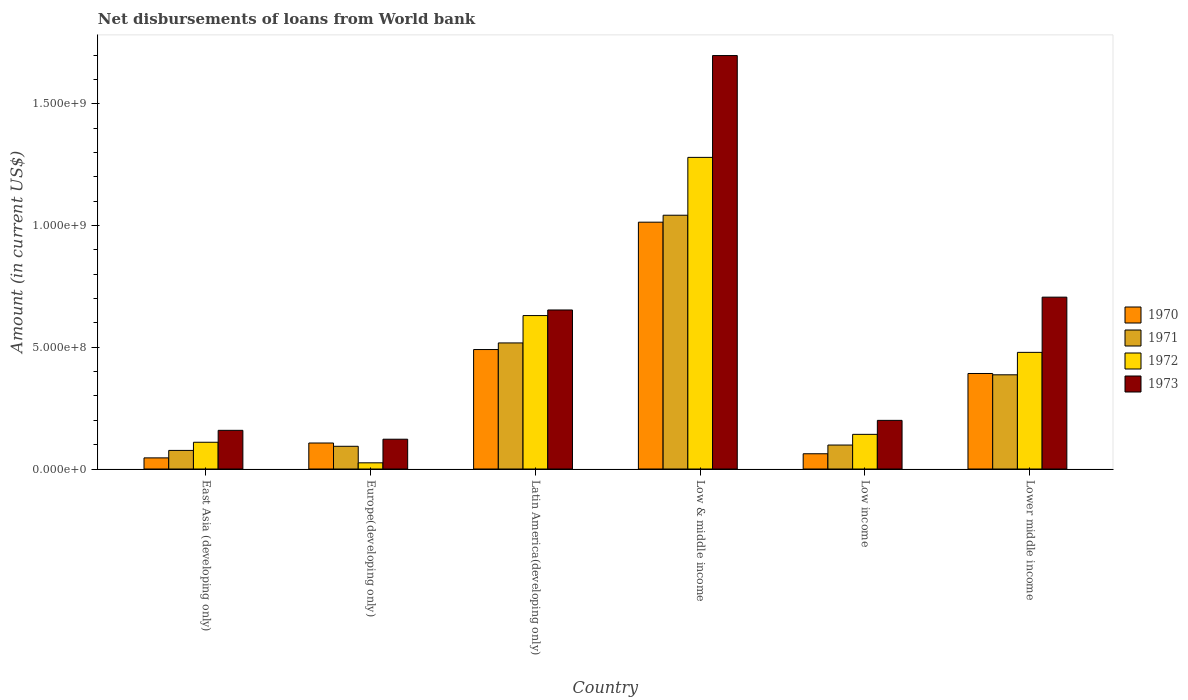How many different coloured bars are there?
Ensure brevity in your answer.  4. How many groups of bars are there?
Provide a succinct answer. 6. Are the number of bars per tick equal to the number of legend labels?
Provide a succinct answer. Yes. How many bars are there on the 4th tick from the left?
Offer a very short reply. 4. What is the label of the 2nd group of bars from the left?
Your answer should be compact. Europe(developing only). What is the amount of loan disbursed from World Bank in 1972 in Low income?
Keep it short and to the point. 1.42e+08. Across all countries, what is the maximum amount of loan disbursed from World Bank in 1970?
Give a very brief answer. 1.01e+09. Across all countries, what is the minimum amount of loan disbursed from World Bank in 1973?
Provide a succinct answer. 1.22e+08. In which country was the amount of loan disbursed from World Bank in 1972 maximum?
Offer a terse response. Low & middle income. In which country was the amount of loan disbursed from World Bank in 1970 minimum?
Offer a terse response. East Asia (developing only). What is the total amount of loan disbursed from World Bank in 1972 in the graph?
Keep it short and to the point. 2.67e+09. What is the difference between the amount of loan disbursed from World Bank in 1971 in Latin America(developing only) and that in Low income?
Offer a very short reply. 4.19e+08. What is the difference between the amount of loan disbursed from World Bank in 1973 in Low income and the amount of loan disbursed from World Bank in 1971 in Low & middle income?
Provide a succinct answer. -8.43e+08. What is the average amount of loan disbursed from World Bank in 1970 per country?
Ensure brevity in your answer.  3.52e+08. What is the difference between the amount of loan disbursed from World Bank of/in 1972 and amount of loan disbursed from World Bank of/in 1971 in Europe(developing only)?
Provide a short and direct response. -6.79e+07. What is the ratio of the amount of loan disbursed from World Bank in 1971 in East Asia (developing only) to that in Low & middle income?
Provide a short and direct response. 0.07. Is the difference between the amount of loan disbursed from World Bank in 1972 in East Asia (developing only) and Latin America(developing only) greater than the difference between the amount of loan disbursed from World Bank in 1971 in East Asia (developing only) and Latin America(developing only)?
Give a very brief answer. No. What is the difference between the highest and the second highest amount of loan disbursed from World Bank in 1973?
Keep it short and to the point. 1.05e+09. What is the difference between the highest and the lowest amount of loan disbursed from World Bank in 1973?
Ensure brevity in your answer.  1.58e+09. In how many countries, is the amount of loan disbursed from World Bank in 1970 greater than the average amount of loan disbursed from World Bank in 1970 taken over all countries?
Keep it short and to the point. 3. Is the sum of the amount of loan disbursed from World Bank in 1972 in Europe(developing only) and Low income greater than the maximum amount of loan disbursed from World Bank in 1973 across all countries?
Offer a very short reply. No. Is it the case that in every country, the sum of the amount of loan disbursed from World Bank in 1971 and amount of loan disbursed from World Bank in 1973 is greater than the sum of amount of loan disbursed from World Bank in 1972 and amount of loan disbursed from World Bank in 1970?
Make the answer very short. No. What does the 4th bar from the right in Lower middle income represents?
Provide a succinct answer. 1970. Is it the case that in every country, the sum of the amount of loan disbursed from World Bank in 1973 and amount of loan disbursed from World Bank in 1970 is greater than the amount of loan disbursed from World Bank in 1972?
Give a very brief answer. Yes. Are all the bars in the graph horizontal?
Offer a terse response. No. Does the graph contain grids?
Ensure brevity in your answer.  No. What is the title of the graph?
Your answer should be compact. Net disbursements of loans from World bank. Does "1965" appear as one of the legend labels in the graph?
Make the answer very short. No. What is the label or title of the X-axis?
Your response must be concise. Country. What is the Amount (in current US$) of 1970 in East Asia (developing only)?
Keep it short and to the point. 4.58e+07. What is the Amount (in current US$) of 1971 in East Asia (developing only)?
Ensure brevity in your answer.  7.65e+07. What is the Amount (in current US$) of 1972 in East Asia (developing only)?
Provide a short and direct response. 1.10e+08. What is the Amount (in current US$) in 1973 in East Asia (developing only)?
Offer a very short reply. 1.59e+08. What is the Amount (in current US$) in 1970 in Europe(developing only)?
Provide a short and direct response. 1.07e+08. What is the Amount (in current US$) of 1971 in Europe(developing only)?
Offer a very short reply. 9.34e+07. What is the Amount (in current US$) in 1972 in Europe(developing only)?
Provide a succinct answer. 2.54e+07. What is the Amount (in current US$) in 1973 in Europe(developing only)?
Your answer should be compact. 1.22e+08. What is the Amount (in current US$) of 1970 in Latin America(developing only)?
Your response must be concise. 4.91e+08. What is the Amount (in current US$) of 1971 in Latin America(developing only)?
Make the answer very short. 5.18e+08. What is the Amount (in current US$) of 1972 in Latin America(developing only)?
Provide a short and direct response. 6.30e+08. What is the Amount (in current US$) in 1973 in Latin America(developing only)?
Offer a very short reply. 6.53e+08. What is the Amount (in current US$) of 1970 in Low & middle income?
Provide a succinct answer. 1.01e+09. What is the Amount (in current US$) of 1971 in Low & middle income?
Provide a succinct answer. 1.04e+09. What is the Amount (in current US$) in 1972 in Low & middle income?
Ensure brevity in your answer.  1.28e+09. What is the Amount (in current US$) in 1973 in Low & middle income?
Provide a succinct answer. 1.70e+09. What is the Amount (in current US$) of 1970 in Low income?
Give a very brief answer. 6.27e+07. What is the Amount (in current US$) of 1971 in Low income?
Make the answer very short. 9.85e+07. What is the Amount (in current US$) of 1972 in Low income?
Make the answer very short. 1.42e+08. What is the Amount (in current US$) of 1973 in Low income?
Your answer should be compact. 2.00e+08. What is the Amount (in current US$) in 1970 in Lower middle income?
Provide a succinct answer. 3.92e+08. What is the Amount (in current US$) in 1971 in Lower middle income?
Give a very brief answer. 3.87e+08. What is the Amount (in current US$) of 1972 in Lower middle income?
Offer a very short reply. 4.79e+08. What is the Amount (in current US$) of 1973 in Lower middle income?
Give a very brief answer. 7.06e+08. Across all countries, what is the maximum Amount (in current US$) in 1970?
Your answer should be very brief. 1.01e+09. Across all countries, what is the maximum Amount (in current US$) in 1971?
Your answer should be very brief. 1.04e+09. Across all countries, what is the maximum Amount (in current US$) in 1972?
Make the answer very short. 1.28e+09. Across all countries, what is the maximum Amount (in current US$) in 1973?
Offer a very short reply. 1.70e+09. Across all countries, what is the minimum Amount (in current US$) in 1970?
Keep it short and to the point. 4.58e+07. Across all countries, what is the minimum Amount (in current US$) in 1971?
Make the answer very short. 7.65e+07. Across all countries, what is the minimum Amount (in current US$) in 1972?
Provide a short and direct response. 2.54e+07. Across all countries, what is the minimum Amount (in current US$) in 1973?
Give a very brief answer. 1.22e+08. What is the total Amount (in current US$) of 1970 in the graph?
Provide a short and direct response. 2.11e+09. What is the total Amount (in current US$) in 1971 in the graph?
Keep it short and to the point. 2.22e+09. What is the total Amount (in current US$) in 1972 in the graph?
Your answer should be compact. 2.67e+09. What is the total Amount (in current US$) of 1973 in the graph?
Offer a terse response. 3.54e+09. What is the difference between the Amount (in current US$) of 1970 in East Asia (developing only) and that in Europe(developing only)?
Provide a succinct answer. -6.11e+07. What is the difference between the Amount (in current US$) of 1971 in East Asia (developing only) and that in Europe(developing only)?
Give a very brief answer. -1.69e+07. What is the difference between the Amount (in current US$) in 1972 in East Asia (developing only) and that in Europe(developing only)?
Provide a succinct answer. 8.45e+07. What is the difference between the Amount (in current US$) in 1973 in East Asia (developing only) and that in Europe(developing only)?
Provide a short and direct response. 3.64e+07. What is the difference between the Amount (in current US$) in 1970 in East Asia (developing only) and that in Latin America(developing only)?
Ensure brevity in your answer.  -4.45e+08. What is the difference between the Amount (in current US$) in 1971 in East Asia (developing only) and that in Latin America(developing only)?
Provide a short and direct response. -4.42e+08. What is the difference between the Amount (in current US$) in 1972 in East Asia (developing only) and that in Latin America(developing only)?
Make the answer very short. -5.20e+08. What is the difference between the Amount (in current US$) in 1973 in East Asia (developing only) and that in Latin America(developing only)?
Provide a succinct answer. -4.94e+08. What is the difference between the Amount (in current US$) in 1970 in East Asia (developing only) and that in Low & middle income?
Ensure brevity in your answer.  -9.68e+08. What is the difference between the Amount (in current US$) in 1971 in East Asia (developing only) and that in Low & middle income?
Your answer should be very brief. -9.66e+08. What is the difference between the Amount (in current US$) of 1972 in East Asia (developing only) and that in Low & middle income?
Offer a terse response. -1.17e+09. What is the difference between the Amount (in current US$) in 1973 in East Asia (developing only) and that in Low & middle income?
Offer a very short reply. -1.54e+09. What is the difference between the Amount (in current US$) of 1970 in East Asia (developing only) and that in Low income?
Give a very brief answer. -1.70e+07. What is the difference between the Amount (in current US$) in 1971 in East Asia (developing only) and that in Low income?
Your response must be concise. -2.21e+07. What is the difference between the Amount (in current US$) of 1972 in East Asia (developing only) and that in Low income?
Provide a short and direct response. -3.25e+07. What is the difference between the Amount (in current US$) in 1973 in East Asia (developing only) and that in Low income?
Keep it short and to the point. -4.10e+07. What is the difference between the Amount (in current US$) in 1970 in East Asia (developing only) and that in Lower middle income?
Offer a terse response. -3.47e+08. What is the difference between the Amount (in current US$) of 1971 in East Asia (developing only) and that in Lower middle income?
Provide a succinct answer. -3.11e+08. What is the difference between the Amount (in current US$) in 1972 in East Asia (developing only) and that in Lower middle income?
Provide a short and direct response. -3.69e+08. What is the difference between the Amount (in current US$) in 1973 in East Asia (developing only) and that in Lower middle income?
Make the answer very short. -5.47e+08. What is the difference between the Amount (in current US$) in 1970 in Europe(developing only) and that in Latin America(developing only)?
Keep it short and to the point. -3.84e+08. What is the difference between the Amount (in current US$) of 1971 in Europe(developing only) and that in Latin America(developing only)?
Give a very brief answer. -4.25e+08. What is the difference between the Amount (in current US$) of 1972 in Europe(developing only) and that in Latin America(developing only)?
Offer a very short reply. -6.05e+08. What is the difference between the Amount (in current US$) in 1973 in Europe(developing only) and that in Latin America(developing only)?
Your answer should be very brief. -5.31e+08. What is the difference between the Amount (in current US$) in 1970 in Europe(developing only) and that in Low & middle income?
Keep it short and to the point. -9.07e+08. What is the difference between the Amount (in current US$) of 1971 in Europe(developing only) and that in Low & middle income?
Offer a very short reply. -9.49e+08. What is the difference between the Amount (in current US$) of 1972 in Europe(developing only) and that in Low & middle income?
Give a very brief answer. -1.25e+09. What is the difference between the Amount (in current US$) of 1973 in Europe(developing only) and that in Low & middle income?
Keep it short and to the point. -1.58e+09. What is the difference between the Amount (in current US$) of 1970 in Europe(developing only) and that in Low income?
Ensure brevity in your answer.  4.42e+07. What is the difference between the Amount (in current US$) of 1971 in Europe(developing only) and that in Low income?
Ensure brevity in your answer.  -5.14e+06. What is the difference between the Amount (in current US$) of 1972 in Europe(developing only) and that in Low income?
Make the answer very short. -1.17e+08. What is the difference between the Amount (in current US$) of 1973 in Europe(developing only) and that in Low income?
Your answer should be very brief. -7.74e+07. What is the difference between the Amount (in current US$) in 1970 in Europe(developing only) and that in Lower middle income?
Offer a terse response. -2.86e+08. What is the difference between the Amount (in current US$) of 1971 in Europe(developing only) and that in Lower middle income?
Give a very brief answer. -2.94e+08. What is the difference between the Amount (in current US$) of 1972 in Europe(developing only) and that in Lower middle income?
Your answer should be very brief. -4.54e+08. What is the difference between the Amount (in current US$) in 1973 in Europe(developing only) and that in Lower middle income?
Your response must be concise. -5.84e+08. What is the difference between the Amount (in current US$) in 1970 in Latin America(developing only) and that in Low & middle income?
Provide a short and direct response. -5.23e+08. What is the difference between the Amount (in current US$) of 1971 in Latin America(developing only) and that in Low & middle income?
Give a very brief answer. -5.25e+08. What is the difference between the Amount (in current US$) of 1972 in Latin America(developing only) and that in Low & middle income?
Offer a terse response. -6.50e+08. What is the difference between the Amount (in current US$) in 1973 in Latin America(developing only) and that in Low & middle income?
Offer a terse response. -1.05e+09. What is the difference between the Amount (in current US$) of 1970 in Latin America(developing only) and that in Low income?
Provide a succinct answer. 4.28e+08. What is the difference between the Amount (in current US$) of 1971 in Latin America(developing only) and that in Low income?
Your response must be concise. 4.19e+08. What is the difference between the Amount (in current US$) of 1972 in Latin America(developing only) and that in Low income?
Give a very brief answer. 4.88e+08. What is the difference between the Amount (in current US$) of 1973 in Latin America(developing only) and that in Low income?
Your answer should be compact. 4.54e+08. What is the difference between the Amount (in current US$) in 1970 in Latin America(developing only) and that in Lower middle income?
Provide a succinct answer. 9.84e+07. What is the difference between the Amount (in current US$) of 1971 in Latin America(developing only) and that in Lower middle income?
Provide a short and direct response. 1.31e+08. What is the difference between the Amount (in current US$) in 1972 in Latin America(developing only) and that in Lower middle income?
Offer a terse response. 1.51e+08. What is the difference between the Amount (in current US$) of 1973 in Latin America(developing only) and that in Lower middle income?
Make the answer very short. -5.27e+07. What is the difference between the Amount (in current US$) in 1970 in Low & middle income and that in Low income?
Offer a terse response. 9.51e+08. What is the difference between the Amount (in current US$) in 1971 in Low & middle income and that in Low income?
Offer a terse response. 9.44e+08. What is the difference between the Amount (in current US$) of 1972 in Low & middle income and that in Low income?
Make the answer very short. 1.14e+09. What is the difference between the Amount (in current US$) in 1973 in Low & middle income and that in Low income?
Your answer should be very brief. 1.50e+09. What is the difference between the Amount (in current US$) in 1970 in Low & middle income and that in Lower middle income?
Ensure brevity in your answer.  6.22e+08. What is the difference between the Amount (in current US$) of 1971 in Low & middle income and that in Lower middle income?
Provide a succinct answer. 6.56e+08. What is the difference between the Amount (in current US$) in 1972 in Low & middle income and that in Lower middle income?
Your answer should be very brief. 8.01e+08. What is the difference between the Amount (in current US$) of 1973 in Low & middle income and that in Lower middle income?
Your answer should be compact. 9.93e+08. What is the difference between the Amount (in current US$) in 1970 in Low income and that in Lower middle income?
Your answer should be very brief. -3.30e+08. What is the difference between the Amount (in current US$) in 1971 in Low income and that in Lower middle income?
Give a very brief answer. -2.89e+08. What is the difference between the Amount (in current US$) of 1972 in Low income and that in Lower middle income?
Your response must be concise. -3.37e+08. What is the difference between the Amount (in current US$) of 1973 in Low income and that in Lower middle income?
Your response must be concise. -5.06e+08. What is the difference between the Amount (in current US$) of 1970 in East Asia (developing only) and the Amount (in current US$) of 1971 in Europe(developing only)?
Ensure brevity in your answer.  -4.76e+07. What is the difference between the Amount (in current US$) of 1970 in East Asia (developing only) and the Amount (in current US$) of 1972 in Europe(developing only)?
Your answer should be compact. 2.03e+07. What is the difference between the Amount (in current US$) of 1970 in East Asia (developing only) and the Amount (in current US$) of 1973 in Europe(developing only)?
Offer a terse response. -7.67e+07. What is the difference between the Amount (in current US$) of 1971 in East Asia (developing only) and the Amount (in current US$) of 1972 in Europe(developing only)?
Offer a terse response. 5.10e+07. What is the difference between the Amount (in current US$) in 1971 in East Asia (developing only) and the Amount (in current US$) in 1973 in Europe(developing only)?
Offer a terse response. -4.60e+07. What is the difference between the Amount (in current US$) in 1972 in East Asia (developing only) and the Amount (in current US$) in 1973 in Europe(developing only)?
Give a very brief answer. -1.25e+07. What is the difference between the Amount (in current US$) in 1970 in East Asia (developing only) and the Amount (in current US$) in 1971 in Latin America(developing only)?
Offer a very short reply. -4.72e+08. What is the difference between the Amount (in current US$) in 1970 in East Asia (developing only) and the Amount (in current US$) in 1972 in Latin America(developing only)?
Give a very brief answer. -5.85e+08. What is the difference between the Amount (in current US$) of 1970 in East Asia (developing only) and the Amount (in current US$) of 1973 in Latin America(developing only)?
Give a very brief answer. -6.08e+08. What is the difference between the Amount (in current US$) of 1971 in East Asia (developing only) and the Amount (in current US$) of 1972 in Latin America(developing only)?
Give a very brief answer. -5.54e+08. What is the difference between the Amount (in current US$) of 1971 in East Asia (developing only) and the Amount (in current US$) of 1973 in Latin America(developing only)?
Make the answer very short. -5.77e+08. What is the difference between the Amount (in current US$) in 1972 in East Asia (developing only) and the Amount (in current US$) in 1973 in Latin America(developing only)?
Offer a very short reply. -5.43e+08. What is the difference between the Amount (in current US$) in 1970 in East Asia (developing only) and the Amount (in current US$) in 1971 in Low & middle income?
Your answer should be compact. -9.97e+08. What is the difference between the Amount (in current US$) in 1970 in East Asia (developing only) and the Amount (in current US$) in 1972 in Low & middle income?
Offer a very short reply. -1.23e+09. What is the difference between the Amount (in current US$) in 1970 in East Asia (developing only) and the Amount (in current US$) in 1973 in Low & middle income?
Ensure brevity in your answer.  -1.65e+09. What is the difference between the Amount (in current US$) in 1971 in East Asia (developing only) and the Amount (in current US$) in 1972 in Low & middle income?
Your answer should be compact. -1.20e+09. What is the difference between the Amount (in current US$) in 1971 in East Asia (developing only) and the Amount (in current US$) in 1973 in Low & middle income?
Your answer should be very brief. -1.62e+09. What is the difference between the Amount (in current US$) in 1972 in East Asia (developing only) and the Amount (in current US$) in 1973 in Low & middle income?
Offer a terse response. -1.59e+09. What is the difference between the Amount (in current US$) of 1970 in East Asia (developing only) and the Amount (in current US$) of 1971 in Low income?
Keep it short and to the point. -5.28e+07. What is the difference between the Amount (in current US$) in 1970 in East Asia (developing only) and the Amount (in current US$) in 1972 in Low income?
Your response must be concise. -9.67e+07. What is the difference between the Amount (in current US$) of 1970 in East Asia (developing only) and the Amount (in current US$) of 1973 in Low income?
Your answer should be compact. -1.54e+08. What is the difference between the Amount (in current US$) of 1971 in East Asia (developing only) and the Amount (in current US$) of 1972 in Low income?
Provide a short and direct response. -6.60e+07. What is the difference between the Amount (in current US$) of 1971 in East Asia (developing only) and the Amount (in current US$) of 1973 in Low income?
Ensure brevity in your answer.  -1.23e+08. What is the difference between the Amount (in current US$) in 1972 in East Asia (developing only) and the Amount (in current US$) in 1973 in Low income?
Keep it short and to the point. -8.99e+07. What is the difference between the Amount (in current US$) of 1970 in East Asia (developing only) and the Amount (in current US$) of 1971 in Lower middle income?
Ensure brevity in your answer.  -3.41e+08. What is the difference between the Amount (in current US$) of 1970 in East Asia (developing only) and the Amount (in current US$) of 1972 in Lower middle income?
Your response must be concise. -4.33e+08. What is the difference between the Amount (in current US$) of 1970 in East Asia (developing only) and the Amount (in current US$) of 1973 in Lower middle income?
Offer a very short reply. -6.60e+08. What is the difference between the Amount (in current US$) in 1971 in East Asia (developing only) and the Amount (in current US$) in 1972 in Lower middle income?
Offer a very short reply. -4.03e+08. What is the difference between the Amount (in current US$) of 1971 in East Asia (developing only) and the Amount (in current US$) of 1973 in Lower middle income?
Offer a very short reply. -6.30e+08. What is the difference between the Amount (in current US$) of 1972 in East Asia (developing only) and the Amount (in current US$) of 1973 in Lower middle income?
Ensure brevity in your answer.  -5.96e+08. What is the difference between the Amount (in current US$) of 1970 in Europe(developing only) and the Amount (in current US$) of 1971 in Latin America(developing only)?
Provide a short and direct response. -4.11e+08. What is the difference between the Amount (in current US$) in 1970 in Europe(developing only) and the Amount (in current US$) in 1972 in Latin America(developing only)?
Ensure brevity in your answer.  -5.24e+08. What is the difference between the Amount (in current US$) of 1970 in Europe(developing only) and the Amount (in current US$) of 1973 in Latin America(developing only)?
Ensure brevity in your answer.  -5.47e+08. What is the difference between the Amount (in current US$) in 1971 in Europe(developing only) and the Amount (in current US$) in 1972 in Latin America(developing only)?
Your answer should be very brief. -5.37e+08. What is the difference between the Amount (in current US$) in 1971 in Europe(developing only) and the Amount (in current US$) in 1973 in Latin America(developing only)?
Ensure brevity in your answer.  -5.60e+08. What is the difference between the Amount (in current US$) in 1972 in Europe(developing only) and the Amount (in current US$) in 1973 in Latin America(developing only)?
Provide a short and direct response. -6.28e+08. What is the difference between the Amount (in current US$) of 1970 in Europe(developing only) and the Amount (in current US$) of 1971 in Low & middle income?
Your response must be concise. -9.36e+08. What is the difference between the Amount (in current US$) of 1970 in Europe(developing only) and the Amount (in current US$) of 1972 in Low & middle income?
Ensure brevity in your answer.  -1.17e+09. What is the difference between the Amount (in current US$) in 1970 in Europe(developing only) and the Amount (in current US$) in 1973 in Low & middle income?
Your answer should be compact. -1.59e+09. What is the difference between the Amount (in current US$) of 1971 in Europe(developing only) and the Amount (in current US$) of 1972 in Low & middle income?
Give a very brief answer. -1.19e+09. What is the difference between the Amount (in current US$) in 1971 in Europe(developing only) and the Amount (in current US$) in 1973 in Low & middle income?
Provide a succinct answer. -1.61e+09. What is the difference between the Amount (in current US$) of 1972 in Europe(developing only) and the Amount (in current US$) of 1973 in Low & middle income?
Offer a very short reply. -1.67e+09. What is the difference between the Amount (in current US$) in 1970 in Europe(developing only) and the Amount (in current US$) in 1971 in Low income?
Provide a short and direct response. 8.36e+06. What is the difference between the Amount (in current US$) in 1970 in Europe(developing only) and the Amount (in current US$) in 1972 in Low income?
Offer a very short reply. -3.55e+07. What is the difference between the Amount (in current US$) of 1970 in Europe(developing only) and the Amount (in current US$) of 1973 in Low income?
Your answer should be compact. -9.30e+07. What is the difference between the Amount (in current US$) of 1971 in Europe(developing only) and the Amount (in current US$) of 1972 in Low income?
Give a very brief answer. -4.90e+07. What is the difference between the Amount (in current US$) in 1971 in Europe(developing only) and the Amount (in current US$) in 1973 in Low income?
Provide a succinct answer. -1.07e+08. What is the difference between the Amount (in current US$) of 1972 in Europe(developing only) and the Amount (in current US$) of 1973 in Low income?
Offer a terse response. -1.74e+08. What is the difference between the Amount (in current US$) in 1970 in Europe(developing only) and the Amount (in current US$) in 1971 in Lower middle income?
Give a very brief answer. -2.80e+08. What is the difference between the Amount (in current US$) in 1970 in Europe(developing only) and the Amount (in current US$) in 1972 in Lower middle income?
Ensure brevity in your answer.  -3.72e+08. What is the difference between the Amount (in current US$) of 1970 in Europe(developing only) and the Amount (in current US$) of 1973 in Lower middle income?
Provide a short and direct response. -5.99e+08. What is the difference between the Amount (in current US$) of 1971 in Europe(developing only) and the Amount (in current US$) of 1972 in Lower middle income?
Ensure brevity in your answer.  -3.86e+08. What is the difference between the Amount (in current US$) of 1971 in Europe(developing only) and the Amount (in current US$) of 1973 in Lower middle income?
Keep it short and to the point. -6.13e+08. What is the difference between the Amount (in current US$) of 1972 in Europe(developing only) and the Amount (in current US$) of 1973 in Lower middle income?
Provide a short and direct response. -6.81e+08. What is the difference between the Amount (in current US$) of 1970 in Latin America(developing only) and the Amount (in current US$) of 1971 in Low & middle income?
Offer a very short reply. -5.52e+08. What is the difference between the Amount (in current US$) in 1970 in Latin America(developing only) and the Amount (in current US$) in 1972 in Low & middle income?
Ensure brevity in your answer.  -7.90e+08. What is the difference between the Amount (in current US$) of 1970 in Latin America(developing only) and the Amount (in current US$) of 1973 in Low & middle income?
Give a very brief answer. -1.21e+09. What is the difference between the Amount (in current US$) in 1971 in Latin America(developing only) and the Amount (in current US$) in 1972 in Low & middle income?
Provide a short and direct response. -7.62e+08. What is the difference between the Amount (in current US$) of 1971 in Latin America(developing only) and the Amount (in current US$) of 1973 in Low & middle income?
Your response must be concise. -1.18e+09. What is the difference between the Amount (in current US$) of 1972 in Latin America(developing only) and the Amount (in current US$) of 1973 in Low & middle income?
Offer a terse response. -1.07e+09. What is the difference between the Amount (in current US$) of 1970 in Latin America(developing only) and the Amount (in current US$) of 1971 in Low income?
Offer a very short reply. 3.92e+08. What is the difference between the Amount (in current US$) of 1970 in Latin America(developing only) and the Amount (in current US$) of 1972 in Low income?
Your answer should be very brief. 3.48e+08. What is the difference between the Amount (in current US$) in 1970 in Latin America(developing only) and the Amount (in current US$) in 1973 in Low income?
Offer a very short reply. 2.91e+08. What is the difference between the Amount (in current US$) of 1971 in Latin America(developing only) and the Amount (in current US$) of 1972 in Low income?
Offer a very short reply. 3.76e+08. What is the difference between the Amount (in current US$) of 1971 in Latin America(developing only) and the Amount (in current US$) of 1973 in Low income?
Your response must be concise. 3.18e+08. What is the difference between the Amount (in current US$) of 1972 in Latin America(developing only) and the Amount (in current US$) of 1973 in Low income?
Provide a succinct answer. 4.31e+08. What is the difference between the Amount (in current US$) in 1970 in Latin America(developing only) and the Amount (in current US$) in 1971 in Lower middle income?
Your answer should be compact. 1.04e+08. What is the difference between the Amount (in current US$) of 1970 in Latin America(developing only) and the Amount (in current US$) of 1972 in Lower middle income?
Give a very brief answer. 1.16e+07. What is the difference between the Amount (in current US$) in 1970 in Latin America(developing only) and the Amount (in current US$) in 1973 in Lower middle income?
Your answer should be compact. -2.15e+08. What is the difference between the Amount (in current US$) in 1971 in Latin America(developing only) and the Amount (in current US$) in 1972 in Lower middle income?
Make the answer very short. 3.88e+07. What is the difference between the Amount (in current US$) of 1971 in Latin America(developing only) and the Amount (in current US$) of 1973 in Lower middle income?
Provide a succinct answer. -1.88e+08. What is the difference between the Amount (in current US$) in 1972 in Latin America(developing only) and the Amount (in current US$) in 1973 in Lower middle income?
Your response must be concise. -7.57e+07. What is the difference between the Amount (in current US$) of 1970 in Low & middle income and the Amount (in current US$) of 1971 in Low income?
Give a very brief answer. 9.16e+08. What is the difference between the Amount (in current US$) of 1970 in Low & middle income and the Amount (in current US$) of 1972 in Low income?
Your answer should be very brief. 8.72e+08. What is the difference between the Amount (in current US$) in 1970 in Low & middle income and the Amount (in current US$) in 1973 in Low income?
Offer a terse response. 8.14e+08. What is the difference between the Amount (in current US$) in 1971 in Low & middle income and the Amount (in current US$) in 1972 in Low income?
Make the answer very short. 9.00e+08. What is the difference between the Amount (in current US$) of 1971 in Low & middle income and the Amount (in current US$) of 1973 in Low income?
Your response must be concise. 8.43e+08. What is the difference between the Amount (in current US$) in 1972 in Low & middle income and the Amount (in current US$) in 1973 in Low income?
Your answer should be very brief. 1.08e+09. What is the difference between the Amount (in current US$) in 1970 in Low & middle income and the Amount (in current US$) in 1971 in Lower middle income?
Ensure brevity in your answer.  6.27e+08. What is the difference between the Amount (in current US$) in 1970 in Low & middle income and the Amount (in current US$) in 1972 in Lower middle income?
Provide a short and direct response. 5.35e+08. What is the difference between the Amount (in current US$) in 1970 in Low & middle income and the Amount (in current US$) in 1973 in Lower middle income?
Ensure brevity in your answer.  3.08e+08. What is the difference between the Amount (in current US$) of 1971 in Low & middle income and the Amount (in current US$) of 1972 in Lower middle income?
Offer a very short reply. 5.63e+08. What is the difference between the Amount (in current US$) in 1971 in Low & middle income and the Amount (in current US$) in 1973 in Lower middle income?
Your answer should be compact. 3.37e+08. What is the difference between the Amount (in current US$) of 1972 in Low & middle income and the Amount (in current US$) of 1973 in Lower middle income?
Provide a succinct answer. 5.74e+08. What is the difference between the Amount (in current US$) of 1970 in Low income and the Amount (in current US$) of 1971 in Lower middle income?
Ensure brevity in your answer.  -3.24e+08. What is the difference between the Amount (in current US$) in 1970 in Low income and the Amount (in current US$) in 1972 in Lower middle income?
Offer a very short reply. -4.17e+08. What is the difference between the Amount (in current US$) of 1970 in Low income and the Amount (in current US$) of 1973 in Lower middle income?
Your answer should be very brief. -6.43e+08. What is the difference between the Amount (in current US$) in 1971 in Low income and the Amount (in current US$) in 1972 in Lower middle income?
Ensure brevity in your answer.  -3.81e+08. What is the difference between the Amount (in current US$) of 1971 in Low income and the Amount (in current US$) of 1973 in Lower middle income?
Provide a short and direct response. -6.08e+08. What is the difference between the Amount (in current US$) of 1972 in Low income and the Amount (in current US$) of 1973 in Lower middle income?
Give a very brief answer. -5.64e+08. What is the average Amount (in current US$) of 1970 per country?
Make the answer very short. 3.52e+08. What is the average Amount (in current US$) in 1971 per country?
Your answer should be very brief. 3.69e+08. What is the average Amount (in current US$) in 1972 per country?
Provide a succinct answer. 4.45e+08. What is the average Amount (in current US$) of 1973 per country?
Your answer should be compact. 5.90e+08. What is the difference between the Amount (in current US$) of 1970 and Amount (in current US$) of 1971 in East Asia (developing only)?
Provide a short and direct response. -3.07e+07. What is the difference between the Amount (in current US$) in 1970 and Amount (in current US$) in 1972 in East Asia (developing only)?
Make the answer very short. -6.42e+07. What is the difference between the Amount (in current US$) of 1970 and Amount (in current US$) of 1973 in East Asia (developing only)?
Provide a short and direct response. -1.13e+08. What is the difference between the Amount (in current US$) of 1971 and Amount (in current US$) of 1972 in East Asia (developing only)?
Your answer should be very brief. -3.35e+07. What is the difference between the Amount (in current US$) in 1971 and Amount (in current US$) in 1973 in East Asia (developing only)?
Offer a terse response. -8.24e+07. What is the difference between the Amount (in current US$) in 1972 and Amount (in current US$) in 1973 in East Asia (developing only)?
Ensure brevity in your answer.  -4.90e+07. What is the difference between the Amount (in current US$) of 1970 and Amount (in current US$) of 1971 in Europe(developing only)?
Provide a short and direct response. 1.35e+07. What is the difference between the Amount (in current US$) in 1970 and Amount (in current US$) in 1972 in Europe(developing only)?
Provide a succinct answer. 8.14e+07. What is the difference between the Amount (in current US$) of 1970 and Amount (in current US$) of 1973 in Europe(developing only)?
Offer a terse response. -1.56e+07. What is the difference between the Amount (in current US$) in 1971 and Amount (in current US$) in 1972 in Europe(developing only)?
Keep it short and to the point. 6.79e+07. What is the difference between the Amount (in current US$) of 1971 and Amount (in current US$) of 1973 in Europe(developing only)?
Your response must be concise. -2.91e+07. What is the difference between the Amount (in current US$) in 1972 and Amount (in current US$) in 1973 in Europe(developing only)?
Your answer should be compact. -9.70e+07. What is the difference between the Amount (in current US$) of 1970 and Amount (in current US$) of 1971 in Latin America(developing only)?
Give a very brief answer. -2.71e+07. What is the difference between the Amount (in current US$) of 1970 and Amount (in current US$) of 1972 in Latin America(developing only)?
Offer a very short reply. -1.40e+08. What is the difference between the Amount (in current US$) of 1970 and Amount (in current US$) of 1973 in Latin America(developing only)?
Your answer should be compact. -1.63e+08. What is the difference between the Amount (in current US$) of 1971 and Amount (in current US$) of 1972 in Latin America(developing only)?
Keep it short and to the point. -1.12e+08. What is the difference between the Amount (in current US$) in 1971 and Amount (in current US$) in 1973 in Latin America(developing only)?
Offer a terse response. -1.35e+08. What is the difference between the Amount (in current US$) of 1972 and Amount (in current US$) of 1973 in Latin America(developing only)?
Provide a short and direct response. -2.30e+07. What is the difference between the Amount (in current US$) of 1970 and Amount (in current US$) of 1971 in Low & middle income?
Make the answer very short. -2.86e+07. What is the difference between the Amount (in current US$) of 1970 and Amount (in current US$) of 1972 in Low & middle income?
Offer a terse response. -2.66e+08. What is the difference between the Amount (in current US$) of 1970 and Amount (in current US$) of 1973 in Low & middle income?
Offer a terse response. -6.85e+08. What is the difference between the Amount (in current US$) in 1971 and Amount (in current US$) in 1972 in Low & middle income?
Your answer should be very brief. -2.38e+08. What is the difference between the Amount (in current US$) in 1971 and Amount (in current US$) in 1973 in Low & middle income?
Provide a succinct answer. -6.56e+08. What is the difference between the Amount (in current US$) of 1972 and Amount (in current US$) of 1973 in Low & middle income?
Your answer should be compact. -4.18e+08. What is the difference between the Amount (in current US$) in 1970 and Amount (in current US$) in 1971 in Low income?
Ensure brevity in your answer.  -3.58e+07. What is the difference between the Amount (in current US$) of 1970 and Amount (in current US$) of 1972 in Low income?
Keep it short and to the point. -7.97e+07. What is the difference between the Amount (in current US$) of 1970 and Amount (in current US$) of 1973 in Low income?
Keep it short and to the point. -1.37e+08. What is the difference between the Amount (in current US$) of 1971 and Amount (in current US$) of 1972 in Low income?
Your answer should be compact. -4.39e+07. What is the difference between the Amount (in current US$) in 1971 and Amount (in current US$) in 1973 in Low income?
Offer a very short reply. -1.01e+08. What is the difference between the Amount (in current US$) of 1972 and Amount (in current US$) of 1973 in Low income?
Keep it short and to the point. -5.75e+07. What is the difference between the Amount (in current US$) of 1970 and Amount (in current US$) of 1971 in Lower middle income?
Provide a short and direct response. 5.37e+06. What is the difference between the Amount (in current US$) of 1970 and Amount (in current US$) of 1972 in Lower middle income?
Your response must be concise. -8.68e+07. What is the difference between the Amount (in current US$) of 1970 and Amount (in current US$) of 1973 in Lower middle income?
Provide a short and direct response. -3.14e+08. What is the difference between the Amount (in current US$) in 1971 and Amount (in current US$) in 1972 in Lower middle income?
Offer a very short reply. -9.22e+07. What is the difference between the Amount (in current US$) of 1971 and Amount (in current US$) of 1973 in Lower middle income?
Make the answer very short. -3.19e+08. What is the difference between the Amount (in current US$) of 1972 and Amount (in current US$) of 1973 in Lower middle income?
Your answer should be very brief. -2.27e+08. What is the ratio of the Amount (in current US$) in 1970 in East Asia (developing only) to that in Europe(developing only)?
Offer a terse response. 0.43. What is the ratio of the Amount (in current US$) of 1971 in East Asia (developing only) to that in Europe(developing only)?
Provide a succinct answer. 0.82. What is the ratio of the Amount (in current US$) of 1972 in East Asia (developing only) to that in Europe(developing only)?
Keep it short and to the point. 4.32. What is the ratio of the Amount (in current US$) in 1973 in East Asia (developing only) to that in Europe(developing only)?
Provide a succinct answer. 1.3. What is the ratio of the Amount (in current US$) of 1970 in East Asia (developing only) to that in Latin America(developing only)?
Your answer should be very brief. 0.09. What is the ratio of the Amount (in current US$) in 1971 in East Asia (developing only) to that in Latin America(developing only)?
Your response must be concise. 0.15. What is the ratio of the Amount (in current US$) of 1972 in East Asia (developing only) to that in Latin America(developing only)?
Offer a very short reply. 0.17. What is the ratio of the Amount (in current US$) of 1973 in East Asia (developing only) to that in Latin America(developing only)?
Offer a terse response. 0.24. What is the ratio of the Amount (in current US$) of 1970 in East Asia (developing only) to that in Low & middle income?
Your answer should be compact. 0.05. What is the ratio of the Amount (in current US$) in 1971 in East Asia (developing only) to that in Low & middle income?
Your answer should be compact. 0.07. What is the ratio of the Amount (in current US$) of 1972 in East Asia (developing only) to that in Low & middle income?
Offer a very short reply. 0.09. What is the ratio of the Amount (in current US$) of 1973 in East Asia (developing only) to that in Low & middle income?
Your answer should be compact. 0.09. What is the ratio of the Amount (in current US$) of 1970 in East Asia (developing only) to that in Low income?
Your answer should be compact. 0.73. What is the ratio of the Amount (in current US$) of 1971 in East Asia (developing only) to that in Low income?
Offer a very short reply. 0.78. What is the ratio of the Amount (in current US$) in 1972 in East Asia (developing only) to that in Low income?
Offer a terse response. 0.77. What is the ratio of the Amount (in current US$) in 1973 in East Asia (developing only) to that in Low income?
Ensure brevity in your answer.  0.79. What is the ratio of the Amount (in current US$) of 1970 in East Asia (developing only) to that in Lower middle income?
Offer a terse response. 0.12. What is the ratio of the Amount (in current US$) in 1971 in East Asia (developing only) to that in Lower middle income?
Provide a succinct answer. 0.2. What is the ratio of the Amount (in current US$) of 1972 in East Asia (developing only) to that in Lower middle income?
Your answer should be compact. 0.23. What is the ratio of the Amount (in current US$) of 1973 in East Asia (developing only) to that in Lower middle income?
Your answer should be compact. 0.23. What is the ratio of the Amount (in current US$) of 1970 in Europe(developing only) to that in Latin America(developing only)?
Offer a terse response. 0.22. What is the ratio of the Amount (in current US$) of 1971 in Europe(developing only) to that in Latin America(developing only)?
Your response must be concise. 0.18. What is the ratio of the Amount (in current US$) in 1972 in Europe(developing only) to that in Latin America(developing only)?
Offer a terse response. 0.04. What is the ratio of the Amount (in current US$) in 1973 in Europe(developing only) to that in Latin America(developing only)?
Keep it short and to the point. 0.19. What is the ratio of the Amount (in current US$) in 1970 in Europe(developing only) to that in Low & middle income?
Provide a succinct answer. 0.11. What is the ratio of the Amount (in current US$) in 1971 in Europe(developing only) to that in Low & middle income?
Offer a terse response. 0.09. What is the ratio of the Amount (in current US$) in 1972 in Europe(developing only) to that in Low & middle income?
Offer a terse response. 0.02. What is the ratio of the Amount (in current US$) of 1973 in Europe(developing only) to that in Low & middle income?
Your answer should be very brief. 0.07. What is the ratio of the Amount (in current US$) of 1970 in Europe(developing only) to that in Low income?
Ensure brevity in your answer.  1.7. What is the ratio of the Amount (in current US$) in 1971 in Europe(developing only) to that in Low income?
Provide a short and direct response. 0.95. What is the ratio of the Amount (in current US$) in 1972 in Europe(developing only) to that in Low income?
Your answer should be compact. 0.18. What is the ratio of the Amount (in current US$) of 1973 in Europe(developing only) to that in Low income?
Provide a succinct answer. 0.61. What is the ratio of the Amount (in current US$) of 1970 in Europe(developing only) to that in Lower middle income?
Offer a terse response. 0.27. What is the ratio of the Amount (in current US$) in 1971 in Europe(developing only) to that in Lower middle income?
Ensure brevity in your answer.  0.24. What is the ratio of the Amount (in current US$) in 1972 in Europe(developing only) to that in Lower middle income?
Give a very brief answer. 0.05. What is the ratio of the Amount (in current US$) of 1973 in Europe(developing only) to that in Lower middle income?
Keep it short and to the point. 0.17. What is the ratio of the Amount (in current US$) of 1970 in Latin America(developing only) to that in Low & middle income?
Your answer should be very brief. 0.48. What is the ratio of the Amount (in current US$) in 1971 in Latin America(developing only) to that in Low & middle income?
Make the answer very short. 0.5. What is the ratio of the Amount (in current US$) of 1972 in Latin America(developing only) to that in Low & middle income?
Provide a succinct answer. 0.49. What is the ratio of the Amount (in current US$) of 1973 in Latin America(developing only) to that in Low & middle income?
Keep it short and to the point. 0.38. What is the ratio of the Amount (in current US$) in 1970 in Latin America(developing only) to that in Low income?
Give a very brief answer. 7.83. What is the ratio of the Amount (in current US$) in 1971 in Latin America(developing only) to that in Low income?
Your answer should be very brief. 5.26. What is the ratio of the Amount (in current US$) of 1972 in Latin America(developing only) to that in Low income?
Provide a succinct answer. 4.43. What is the ratio of the Amount (in current US$) of 1973 in Latin America(developing only) to that in Low income?
Provide a short and direct response. 3.27. What is the ratio of the Amount (in current US$) of 1970 in Latin America(developing only) to that in Lower middle income?
Make the answer very short. 1.25. What is the ratio of the Amount (in current US$) in 1971 in Latin America(developing only) to that in Lower middle income?
Offer a terse response. 1.34. What is the ratio of the Amount (in current US$) in 1972 in Latin America(developing only) to that in Lower middle income?
Give a very brief answer. 1.32. What is the ratio of the Amount (in current US$) of 1973 in Latin America(developing only) to that in Lower middle income?
Your answer should be compact. 0.93. What is the ratio of the Amount (in current US$) of 1970 in Low & middle income to that in Low income?
Provide a short and direct response. 16.17. What is the ratio of the Amount (in current US$) of 1971 in Low & middle income to that in Low income?
Offer a terse response. 10.58. What is the ratio of the Amount (in current US$) in 1972 in Low & middle income to that in Low income?
Your answer should be very brief. 8.99. What is the ratio of the Amount (in current US$) in 1973 in Low & middle income to that in Low income?
Your response must be concise. 8.5. What is the ratio of the Amount (in current US$) in 1970 in Low & middle income to that in Lower middle income?
Offer a terse response. 2.58. What is the ratio of the Amount (in current US$) in 1971 in Low & middle income to that in Lower middle income?
Offer a very short reply. 2.69. What is the ratio of the Amount (in current US$) of 1972 in Low & middle income to that in Lower middle income?
Your answer should be compact. 2.67. What is the ratio of the Amount (in current US$) in 1973 in Low & middle income to that in Lower middle income?
Your response must be concise. 2.41. What is the ratio of the Amount (in current US$) of 1970 in Low income to that in Lower middle income?
Keep it short and to the point. 0.16. What is the ratio of the Amount (in current US$) in 1971 in Low income to that in Lower middle income?
Keep it short and to the point. 0.25. What is the ratio of the Amount (in current US$) in 1972 in Low income to that in Lower middle income?
Provide a short and direct response. 0.3. What is the ratio of the Amount (in current US$) of 1973 in Low income to that in Lower middle income?
Offer a terse response. 0.28. What is the difference between the highest and the second highest Amount (in current US$) in 1970?
Your response must be concise. 5.23e+08. What is the difference between the highest and the second highest Amount (in current US$) in 1971?
Give a very brief answer. 5.25e+08. What is the difference between the highest and the second highest Amount (in current US$) in 1972?
Provide a succinct answer. 6.50e+08. What is the difference between the highest and the second highest Amount (in current US$) in 1973?
Offer a very short reply. 9.93e+08. What is the difference between the highest and the lowest Amount (in current US$) of 1970?
Keep it short and to the point. 9.68e+08. What is the difference between the highest and the lowest Amount (in current US$) in 1971?
Offer a very short reply. 9.66e+08. What is the difference between the highest and the lowest Amount (in current US$) of 1972?
Give a very brief answer. 1.25e+09. What is the difference between the highest and the lowest Amount (in current US$) of 1973?
Ensure brevity in your answer.  1.58e+09. 